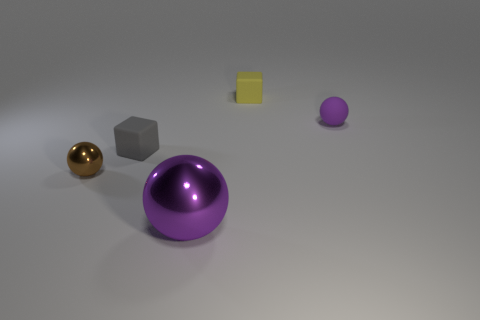There is a object left of the tiny gray rubber block; what material is it?
Offer a terse response. Metal. What is the size of the other rubber thing that is the same color as the big thing?
Provide a short and direct response. Small. Is there a cyan ball that has the same size as the gray matte thing?
Your answer should be compact. No. Is the shape of the gray object the same as the purple object that is behind the large metal ball?
Ensure brevity in your answer.  No. There is a object behind the matte sphere; is it the same size as the metal thing to the right of the small brown ball?
Offer a terse response. No. How many other objects are the same shape as the large purple thing?
Your answer should be compact. 2. What material is the purple sphere that is behind the shiny thing right of the brown metallic sphere?
Offer a terse response. Rubber. What number of metal objects are either tiny yellow things or gray things?
Make the answer very short. 0. Is there any other thing that is the same material as the small brown ball?
Ensure brevity in your answer.  Yes. There is a small matte thing behind the purple matte sphere; is there a tiny purple sphere behind it?
Your response must be concise. No. 